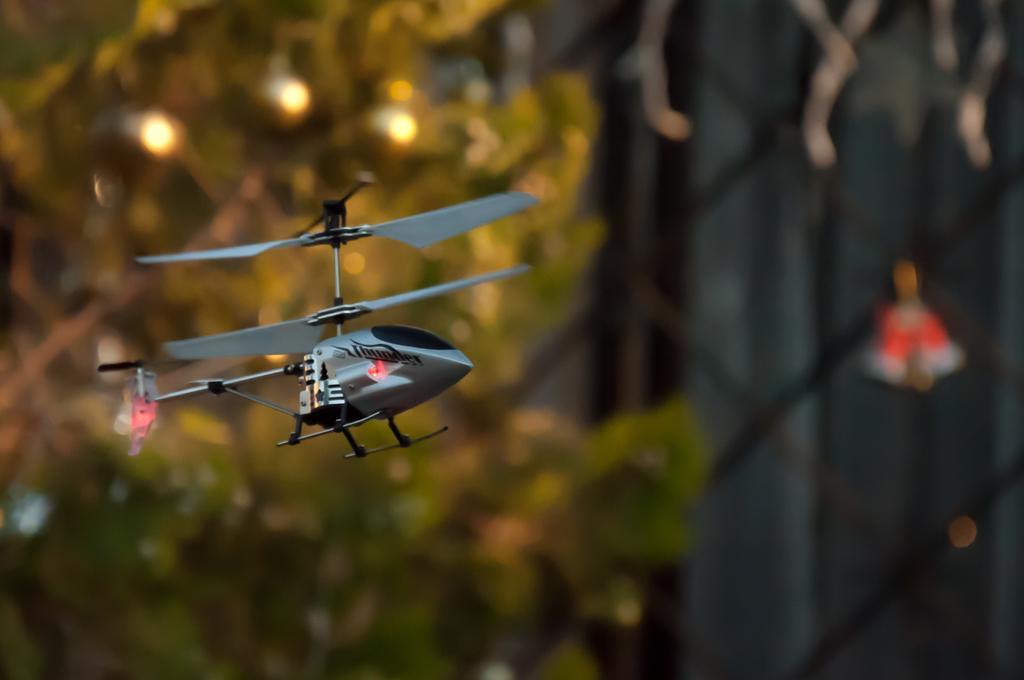What is the main subject in the center of the image? There is a toy helicopter in the center of the image. What can be seen in the background of the image? There are trees in the background of the image. How would you describe the appearance of the background in the image? The background of the image is blurred. What type of friction can be observed between the toy helicopter and the cord in the image? There is no cord present in the image, and therefore no friction can be observed between the toy helicopter and a cord. 